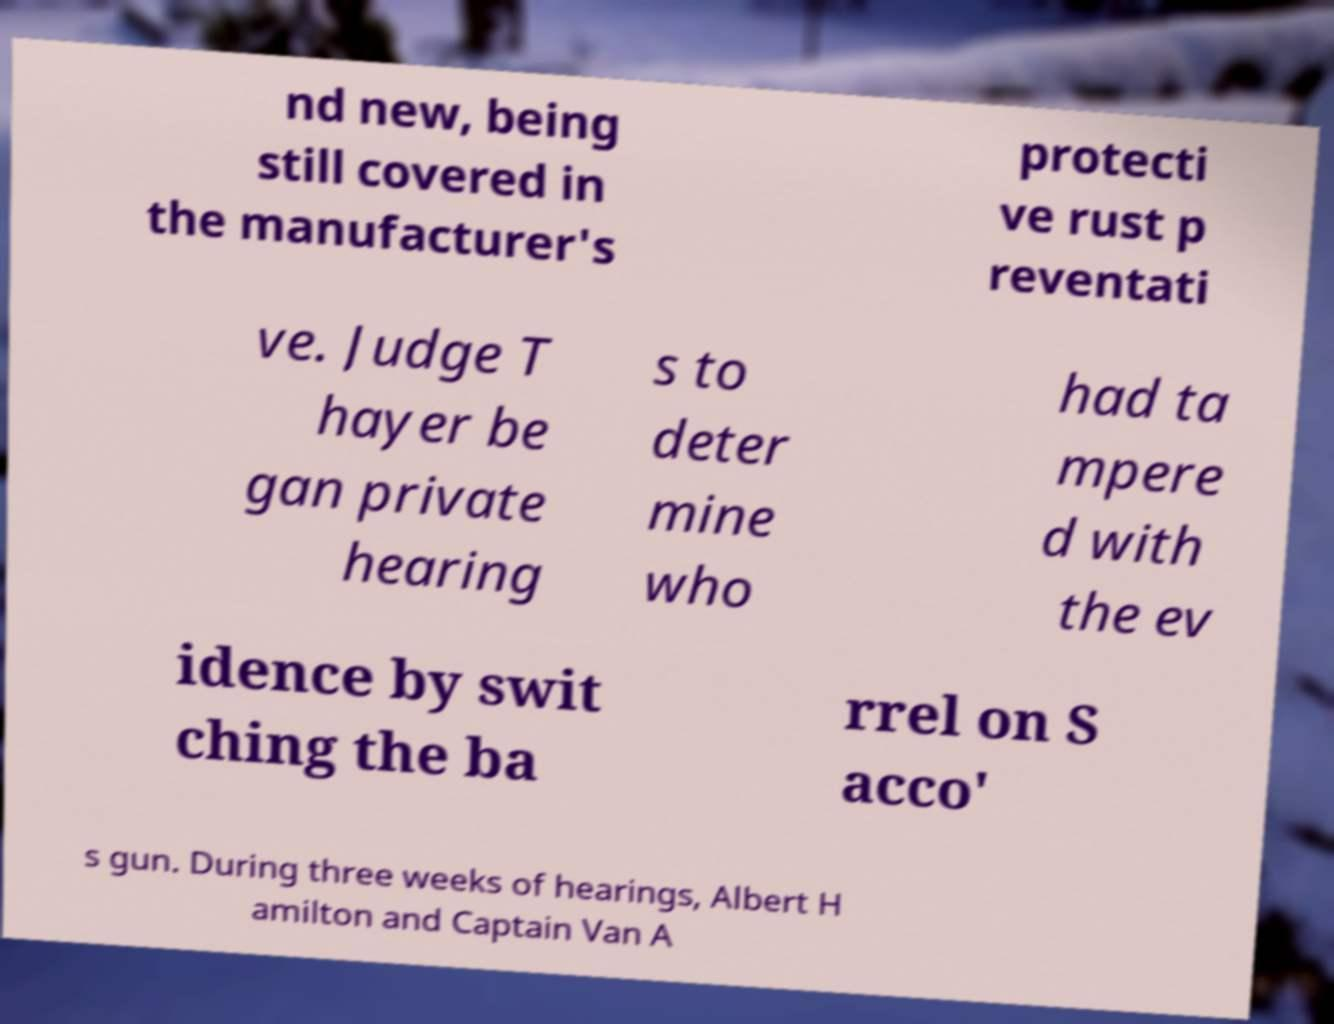For documentation purposes, I need the text within this image transcribed. Could you provide that? nd new, being still covered in the manufacturer's protecti ve rust p reventati ve. Judge T hayer be gan private hearing s to deter mine who had ta mpere d with the ev idence by swit ching the ba rrel on S acco' s gun. During three weeks of hearings, Albert H amilton and Captain Van A 